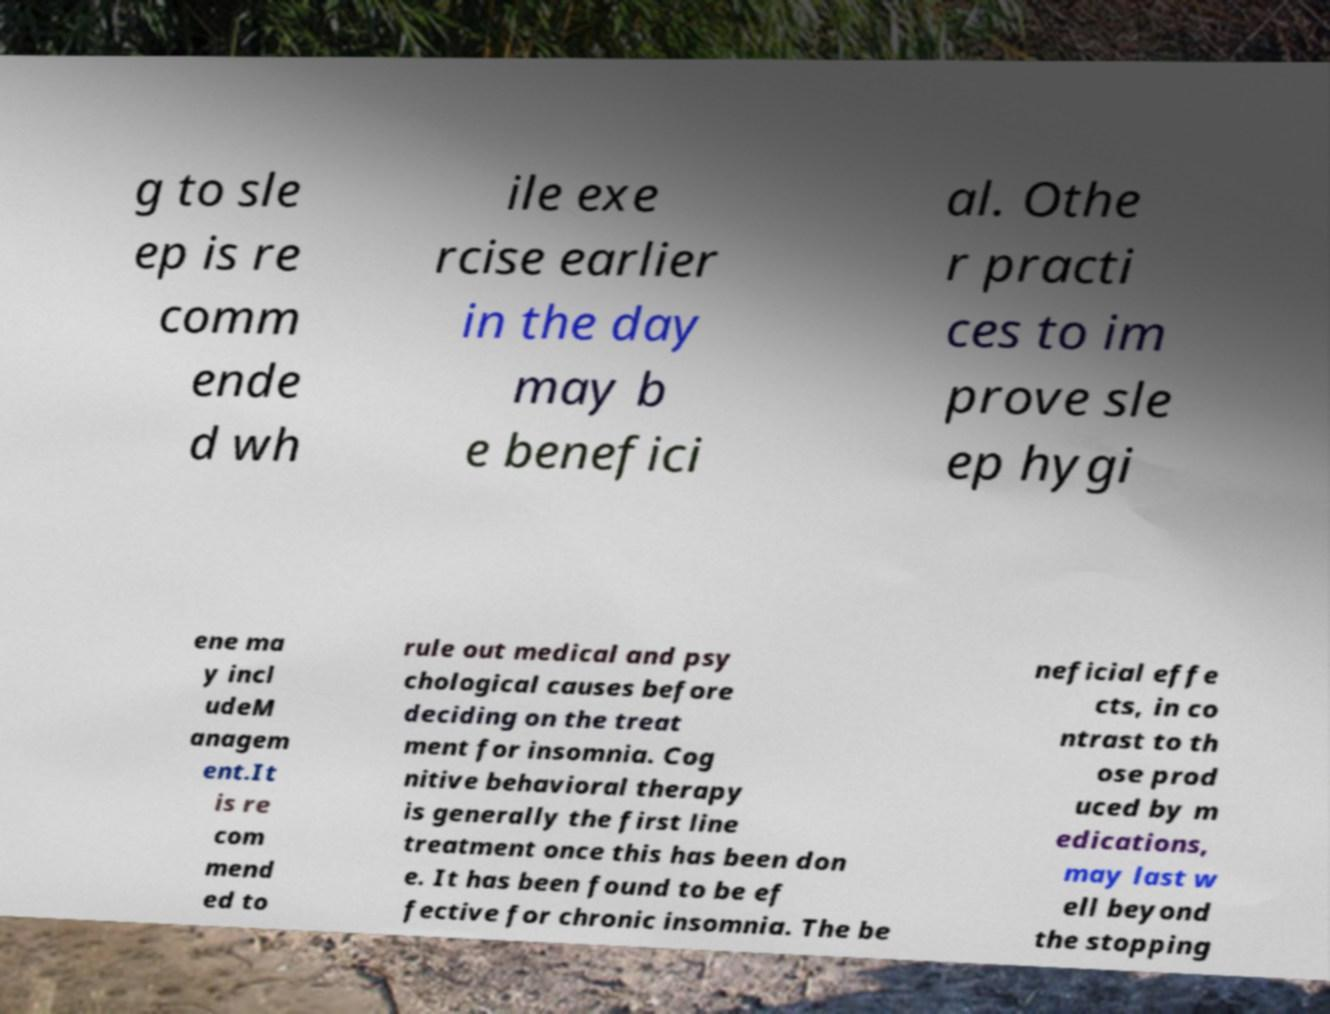Can you accurately transcribe the text from the provided image for me? g to sle ep is re comm ende d wh ile exe rcise earlier in the day may b e benefici al. Othe r practi ces to im prove sle ep hygi ene ma y incl udeM anagem ent.It is re com mend ed to rule out medical and psy chological causes before deciding on the treat ment for insomnia. Cog nitive behavioral therapy is generally the first line treatment once this has been don e. It has been found to be ef fective for chronic insomnia. The be neficial effe cts, in co ntrast to th ose prod uced by m edications, may last w ell beyond the stopping 